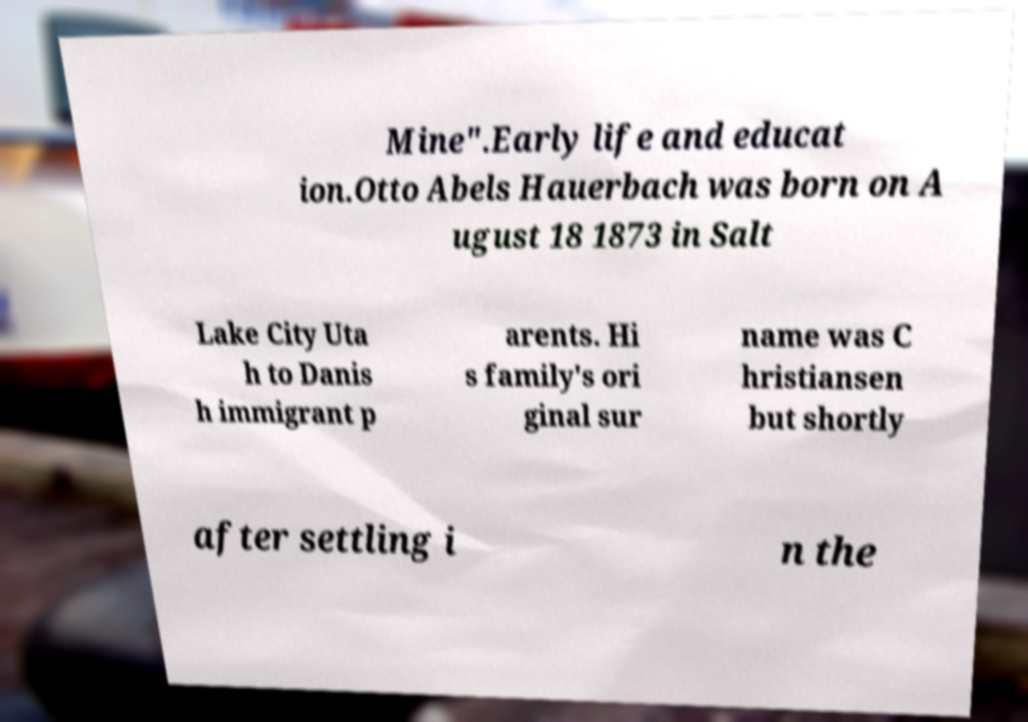Can you accurately transcribe the text from the provided image for me? Mine".Early life and educat ion.Otto Abels Hauerbach was born on A ugust 18 1873 in Salt Lake City Uta h to Danis h immigrant p arents. Hi s family's ori ginal sur name was C hristiansen but shortly after settling i n the 